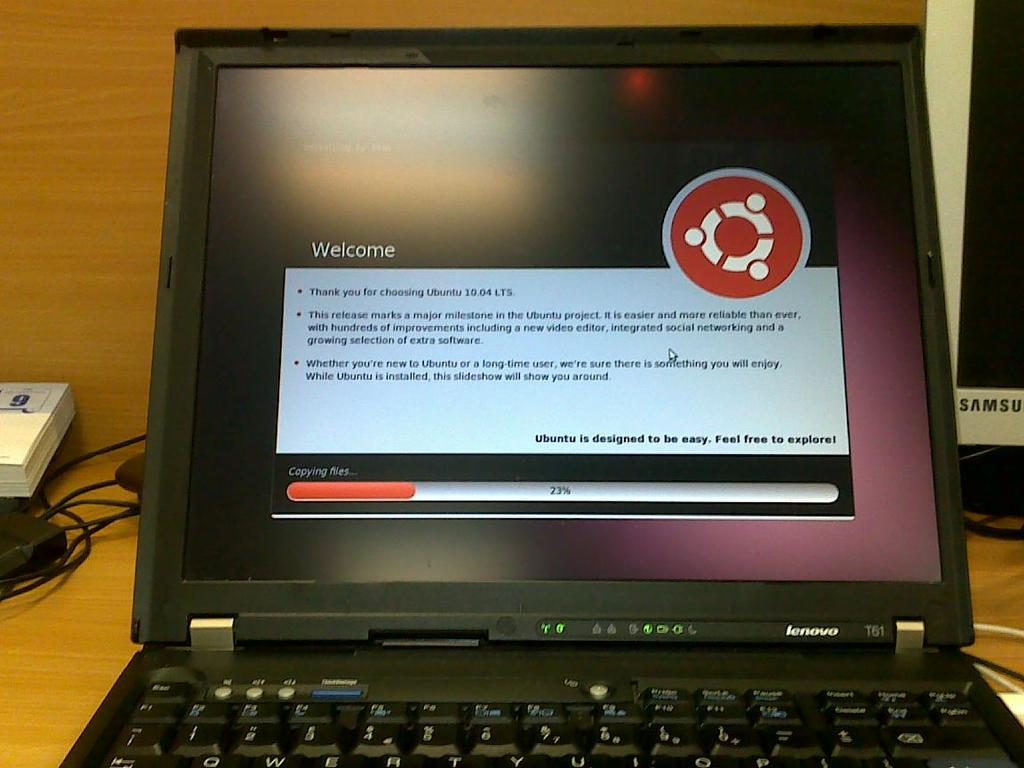Provide a one-sentence caption for the provided image. A black laptop computer with the welcome screen from Ubuntu 10.04 LTS. 